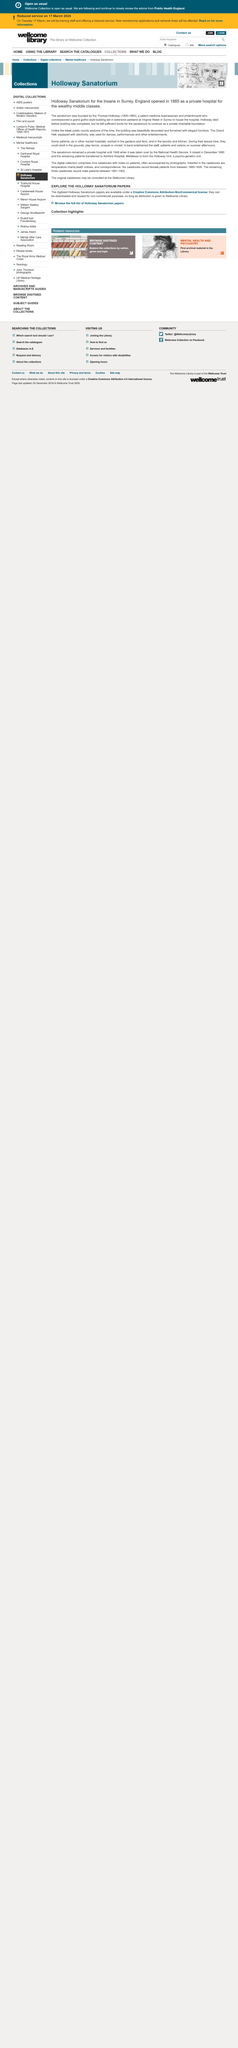List a handful of essential elements in this visual. Holloway Sanatorium for the Insane opened in 1885. The Holloway Sanatorium for the Insane is located in Surrey, England. The Holloway Sanatorium for the Insane was founded by Thomas Holloway. 